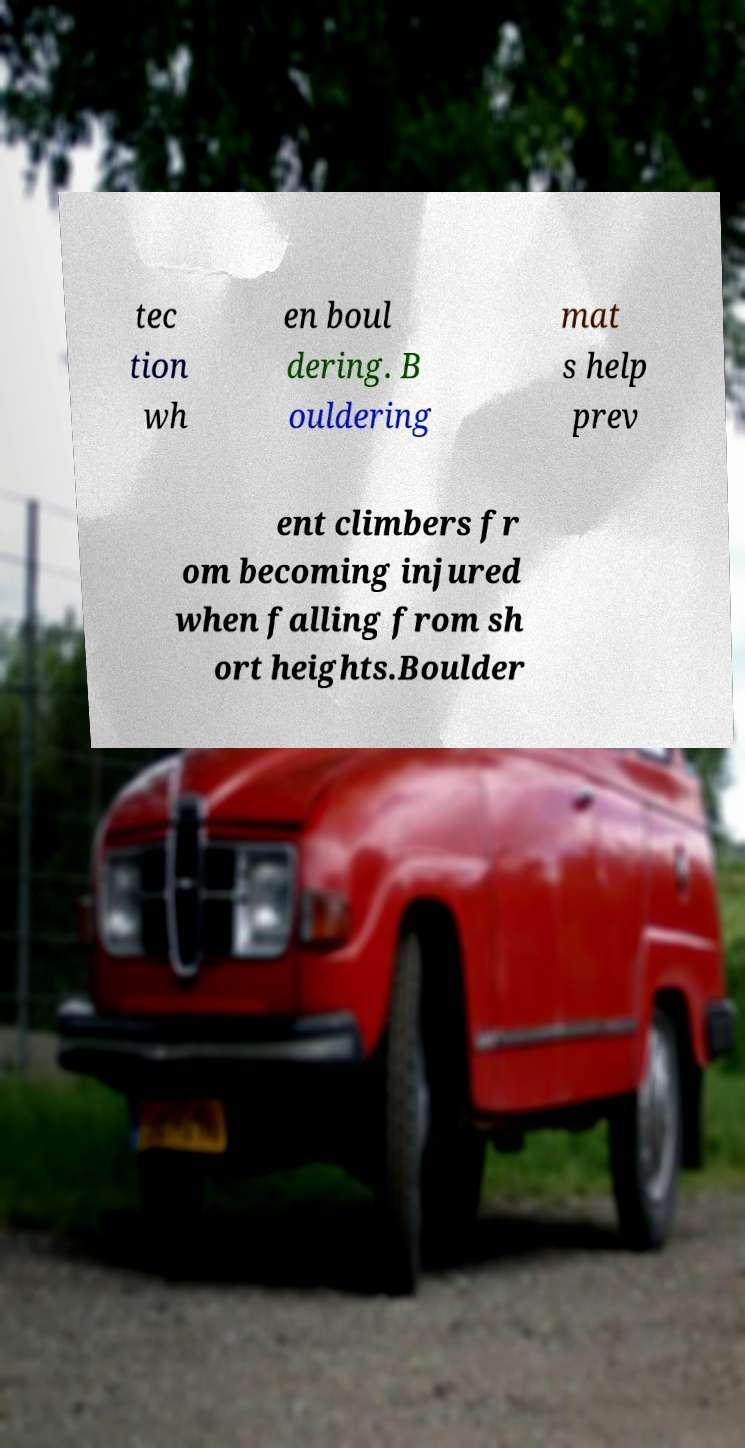What messages or text are displayed in this image? I need them in a readable, typed format. tec tion wh en boul dering. B ouldering mat s help prev ent climbers fr om becoming injured when falling from sh ort heights.Boulder 